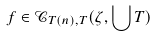Convert formula to latex. <formula><loc_0><loc_0><loc_500><loc_500>f \in \mathcal { C } _ { T ( n ) , T } ( \zeta , \bigcup T )</formula> 